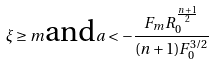Convert formula to latex. <formula><loc_0><loc_0><loc_500><loc_500>\xi \geq m \text {and} a < - \frac { F _ { m } R _ { 0 } ^ { \frac { n + 1 } { 2 } } } { ( n + 1 ) F _ { 0 } ^ { 3 / 2 } }</formula> 